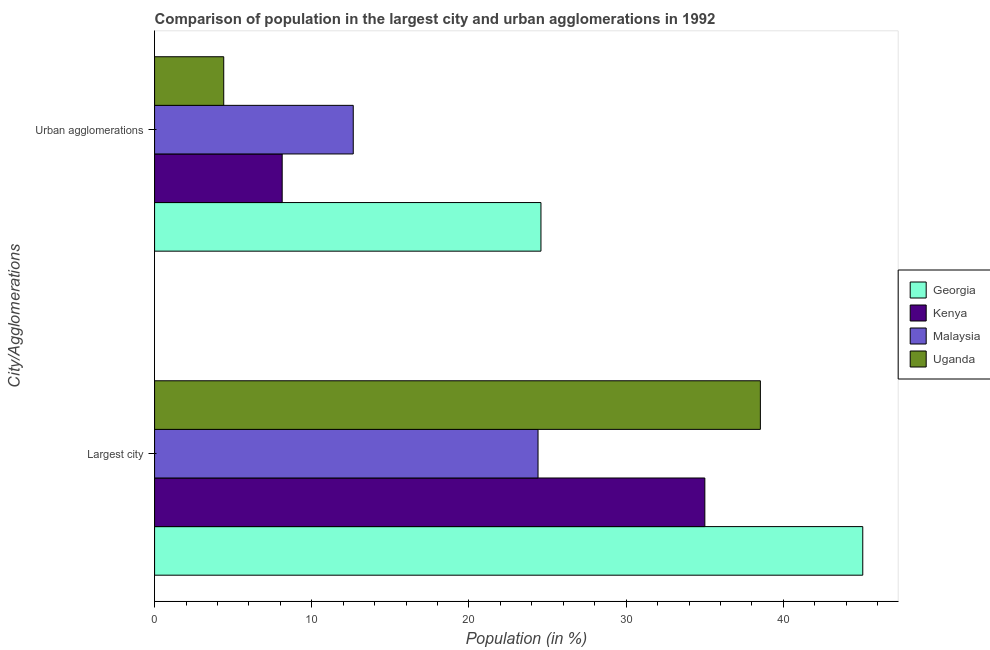How many different coloured bars are there?
Your answer should be compact. 4. How many groups of bars are there?
Your response must be concise. 2. What is the label of the 1st group of bars from the top?
Make the answer very short. Urban agglomerations. What is the population in urban agglomerations in Georgia?
Your response must be concise. 24.58. Across all countries, what is the maximum population in the largest city?
Make the answer very short. 45.05. Across all countries, what is the minimum population in urban agglomerations?
Give a very brief answer. 4.4. In which country was the population in urban agglomerations maximum?
Your response must be concise. Georgia. In which country was the population in urban agglomerations minimum?
Provide a short and direct response. Uganda. What is the total population in urban agglomerations in the graph?
Keep it short and to the point. 49.74. What is the difference between the population in the largest city in Malaysia and that in Kenya?
Your answer should be compact. -10.61. What is the difference between the population in the largest city in Uganda and the population in urban agglomerations in Malaysia?
Ensure brevity in your answer.  25.9. What is the average population in urban agglomerations per country?
Ensure brevity in your answer.  12.43. What is the difference between the population in urban agglomerations and population in the largest city in Kenya?
Ensure brevity in your answer.  -26.89. What is the ratio of the population in the largest city in Uganda to that in Georgia?
Your answer should be compact. 0.86. What does the 1st bar from the top in Largest city represents?
Offer a very short reply. Uganda. What does the 3rd bar from the bottom in Urban agglomerations represents?
Your answer should be very brief. Malaysia. What is the title of the graph?
Your response must be concise. Comparison of population in the largest city and urban agglomerations in 1992. What is the label or title of the Y-axis?
Offer a very short reply. City/Agglomerations. What is the Population (in %) of Georgia in Largest city?
Your answer should be very brief. 45.05. What is the Population (in %) of Kenya in Largest city?
Your answer should be compact. 35.01. What is the Population (in %) in Malaysia in Largest city?
Ensure brevity in your answer.  24.39. What is the Population (in %) in Uganda in Largest city?
Your answer should be compact. 38.54. What is the Population (in %) in Georgia in Urban agglomerations?
Make the answer very short. 24.58. What is the Population (in %) in Kenya in Urban agglomerations?
Ensure brevity in your answer.  8.12. What is the Population (in %) of Malaysia in Urban agglomerations?
Your answer should be compact. 12.64. What is the Population (in %) in Uganda in Urban agglomerations?
Keep it short and to the point. 4.4. Across all City/Agglomerations, what is the maximum Population (in %) in Georgia?
Give a very brief answer. 45.05. Across all City/Agglomerations, what is the maximum Population (in %) of Kenya?
Your answer should be very brief. 35.01. Across all City/Agglomerations, what is the maximum Population (in %) in Malaysia?
Your response must be concise. 24.39. Across all City/Agglomerations, what is the maximum Population (in %) in Uganda?
Your answer should be compact. 38.54. Across all City/Agglomerations, what is the minimum Population (in %) in Georgia?
Make the answer very short. 24.58. Across all City/Agglomerations, what is the minimum Population (in %) in Kenya?
Offer a terse response. 8.12. Across all City/Agglomerations, what is the minimum Population (in %) of Malaysia?
Offer a very short reply. 12.64. Across all City/Agglomerations, what is the minimum Population (in %) in Uganda?
Provide a short and direct response. 4.4. What is the total Population (in %) in Georgia in the graph?
Provide a short and direct response. 69.63. What is the total Population (in %) of Kenya in the graph?
Offer a terse response. 43.13. What is the total Population (in %) of Malaysia in the graph?
Provide a short and direct response. 37.03. What is the total Population (in %) in Uganda in the graph?
Ensure brevity in your answer.  42.94. What is the difference between the Population (in %) of Georgia in Largest city and that in Urban agglomerations?
Make the answer very short. 20.47. What is the difference between the Population (in %) in Kenya in Largest city and that in Urban agglomerations?
Offer a terse response. 26.89. What is the difference between the Population (in %) of Malaysia in Largest city and that in Urban agglomerations?
Keep it short and to the point. 11.75. What is the difference between the Population (in %) of Uganda in Largest city and that in Urban agglomerations?
Make the answer very short. 34.14. What is the difference between the Population (in %) in Georgia in Largest city and the Population (in %) in Kenya in Urban agglomerations?
Offer a very short reply. 36.94. What is the difference between the Population (in %) in Georgia in Largest city and the Population (in %) in Malaysia in Urban agglomerations?
Ensure brevity in your answer.  32.41. What is the difference between the Population (in %) of Georgia in Largest city and the Population (in %) of Uganda in Urban agglomerations?
Offer a terse response. 40.65. What is the difference between the Population (in %) of Kenya in Largest city and the Population (in %) of Malaysia in Urban agglomerations?
Ensure brevity in your answer.  22.37. What is the difference between the Population (in %) of Kenya in Largest city and the Population (in %) of Uganda in Urban agglomerations?
Your answer should be compact. 30.61. What is the difference between the Population (in %) in Malaysia in Largest city and the Population (in %) in Uganda in Urban agglomerations?
Offer a very short reply. 19.99. What is the average Population (in %) in Georgia per City/Agglomerations?
Provide a succinct answer. 34.82. What is the average Population (in %) in Kenya per City/Agglomerations?
Ensure brevity in your answer.  21.56. What is the average Population (in %) of Malaysia per City/Agglomerations?
Offer a terse response. 18.52. What is the average Population (in %) of Uganda per City/Agglomerations?
Keep it short and to the point. 21.47. What is the difference between the Population (in %) of Georgia and Population (in %) of Kenya in Largest city?
Make the answer very short. 10.05. What is the difference between the Population (in %) of Georgia and Population (in %) of Malaysia in Largest city?
Offer a terse response. 20.66. What is the difference between the Population (in %) of Georgia and Population (in %) of Uganda in Largest city?
Your answer should be compact. 6.51. What is the difference between the Population (in %) in Kenya and Population (in %) in Malaysia in Largest city?
Your answer should be very brief. 10.61. What is the difference between the Population (in %) of Kenya and Population (in %) of Uganda in Largest city?
Offer a very short reply. -3.53. What is the difference between the Population (in %) of Malaysia and Population (in %) of Uganda in Largest city?
Your answer should be very brief. -14.14. What is the difference between the Population (in %) in Georgia and Population (in %) in Kenya in Urban agglomerations?
Your answer should be very brief. 16.46. What is the difference between the Population (in %) in Georgia and Population (in %) in Malaysia in Urban agglomerations?
Your answer should be very brief. 11.94. What is the difference between the Population (in %) of Georgia and Population (in %) of Uganda in Urban agglomerations?
Provide a short and direct response. 20.18. What is the difference between the Population (in %) in Kenya and Population (in %) in Malaysia in Urban agglomerations?
Your response must be concise. -4.52. What is the difference between the Population (in %) in Kenya and Population (in %) in Uganda in Urban agglomerations?
Your answer should be very brief. 3.72. What is the difference between the Population (in %) in Malaysia and Population (in %) in Uganda in Urban agglomerations?
Provide a succinct answer. 8.24. What is the ratio of the Population (in %) in Georgia in Largest city to that in Urban agglomerations?
Provide a succinct answer. 1.83. What is the ratio of the Population (in %) in Kenya in Largest city to that in Urban agglomerations?
Your answer should be very brief. 4.31. What is the ratio of the Population (in %) of Malaysia in Largest city to that in Urban agglomerations?
Your answer should be compact. 1.93. What is the ratio of the Population (in %) of Uganda in Largest city to that in Urban agglomerations?
Keep it short and to the point. 8.76. What is the difference between the highest and the second highest Population (in %) in Georgia?
Keep it short and to the point. 20.47. What is the difference between the highest and the second highest Population (in %) in Kenya?
Offer a terse response. 26.89. What is the difference between the highest and the second highest Population (in %) in Malaysia?
Keep it short and to the point. 11.75. What is the difference between the highest and the second highest Population (in %) in Uganda?
Provide a succinct answer. 34.14. What is the difference between the highest and the lowest Population (in %) of Georgia?
Provide a short and direct response. 20.47. What is the difference between the highest and the lowest Population (in %) in Kenya?
Keep it short and to the point. 26.89. What is the difference between the highest and the lowest Population (in %) of Malaysia?
Provide a short and direct response. 11.75. What is the difference between the highest and the lowest Population (in %) in Uganda?
Ensure brevity in your answer.  34.14. 